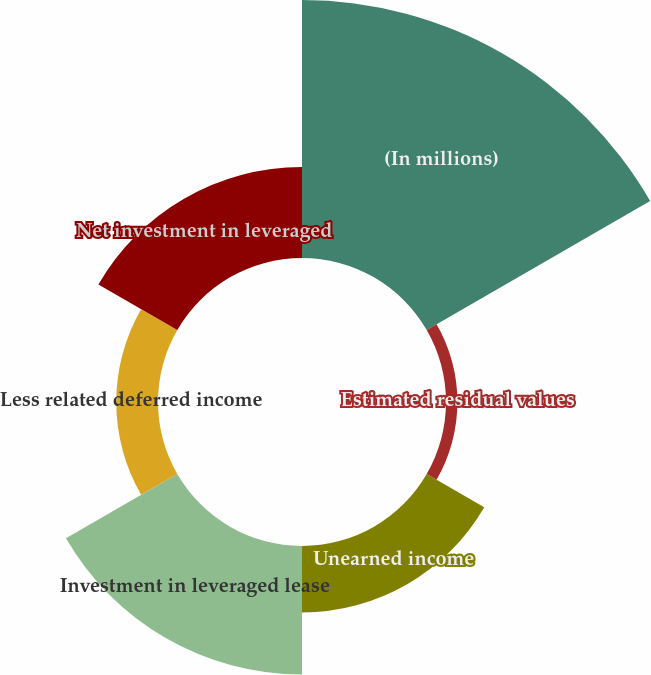<chart> <loc_0><loc_0><loc_500><loc_500><pie_chart><fcel>(In millions)<fcel>Estimated residual values<fcel>Unearned income<fcel>Investment in leveraged lease<fcel>Less related deferred income<fcel>Net investment in leveraged<nl><fcel>43.2%<fcel>1.91%<fcel>11.12%<fcel>21.52%<fcel>6.99%<fcel>15.25%<nl></chart> 